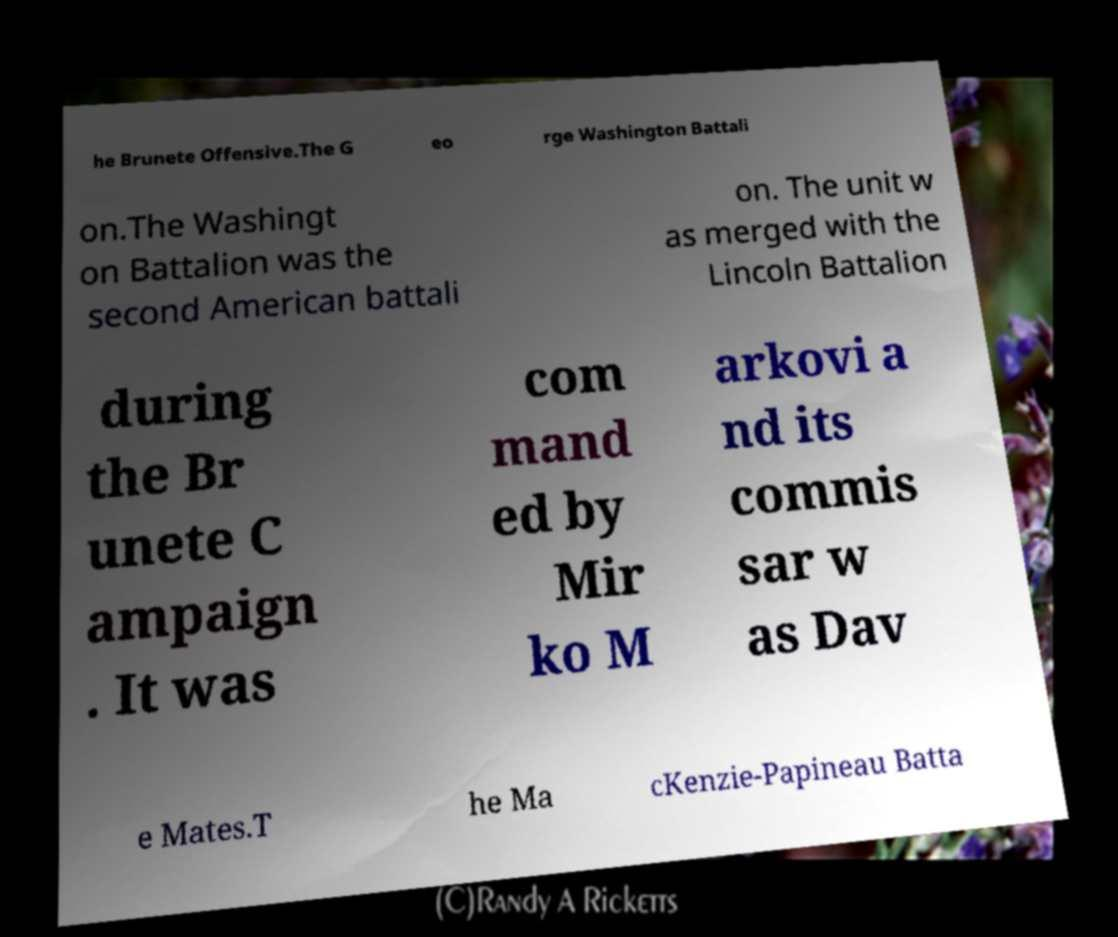There's text embedded in this image that I need extracted. Can you transcribe it verbatim? he Brunete Offensive.The G eo rge Washington Battali on.The Washingt on Battalion was the second American battali on. The unit w as merged with the Lincoln Battalion during the Br unete C ampaign . It was com mand ed by Mir ko M arkovi a nd its commis sar w as Dav e Mates.T he Ma cKenzie-Papineau Batta 